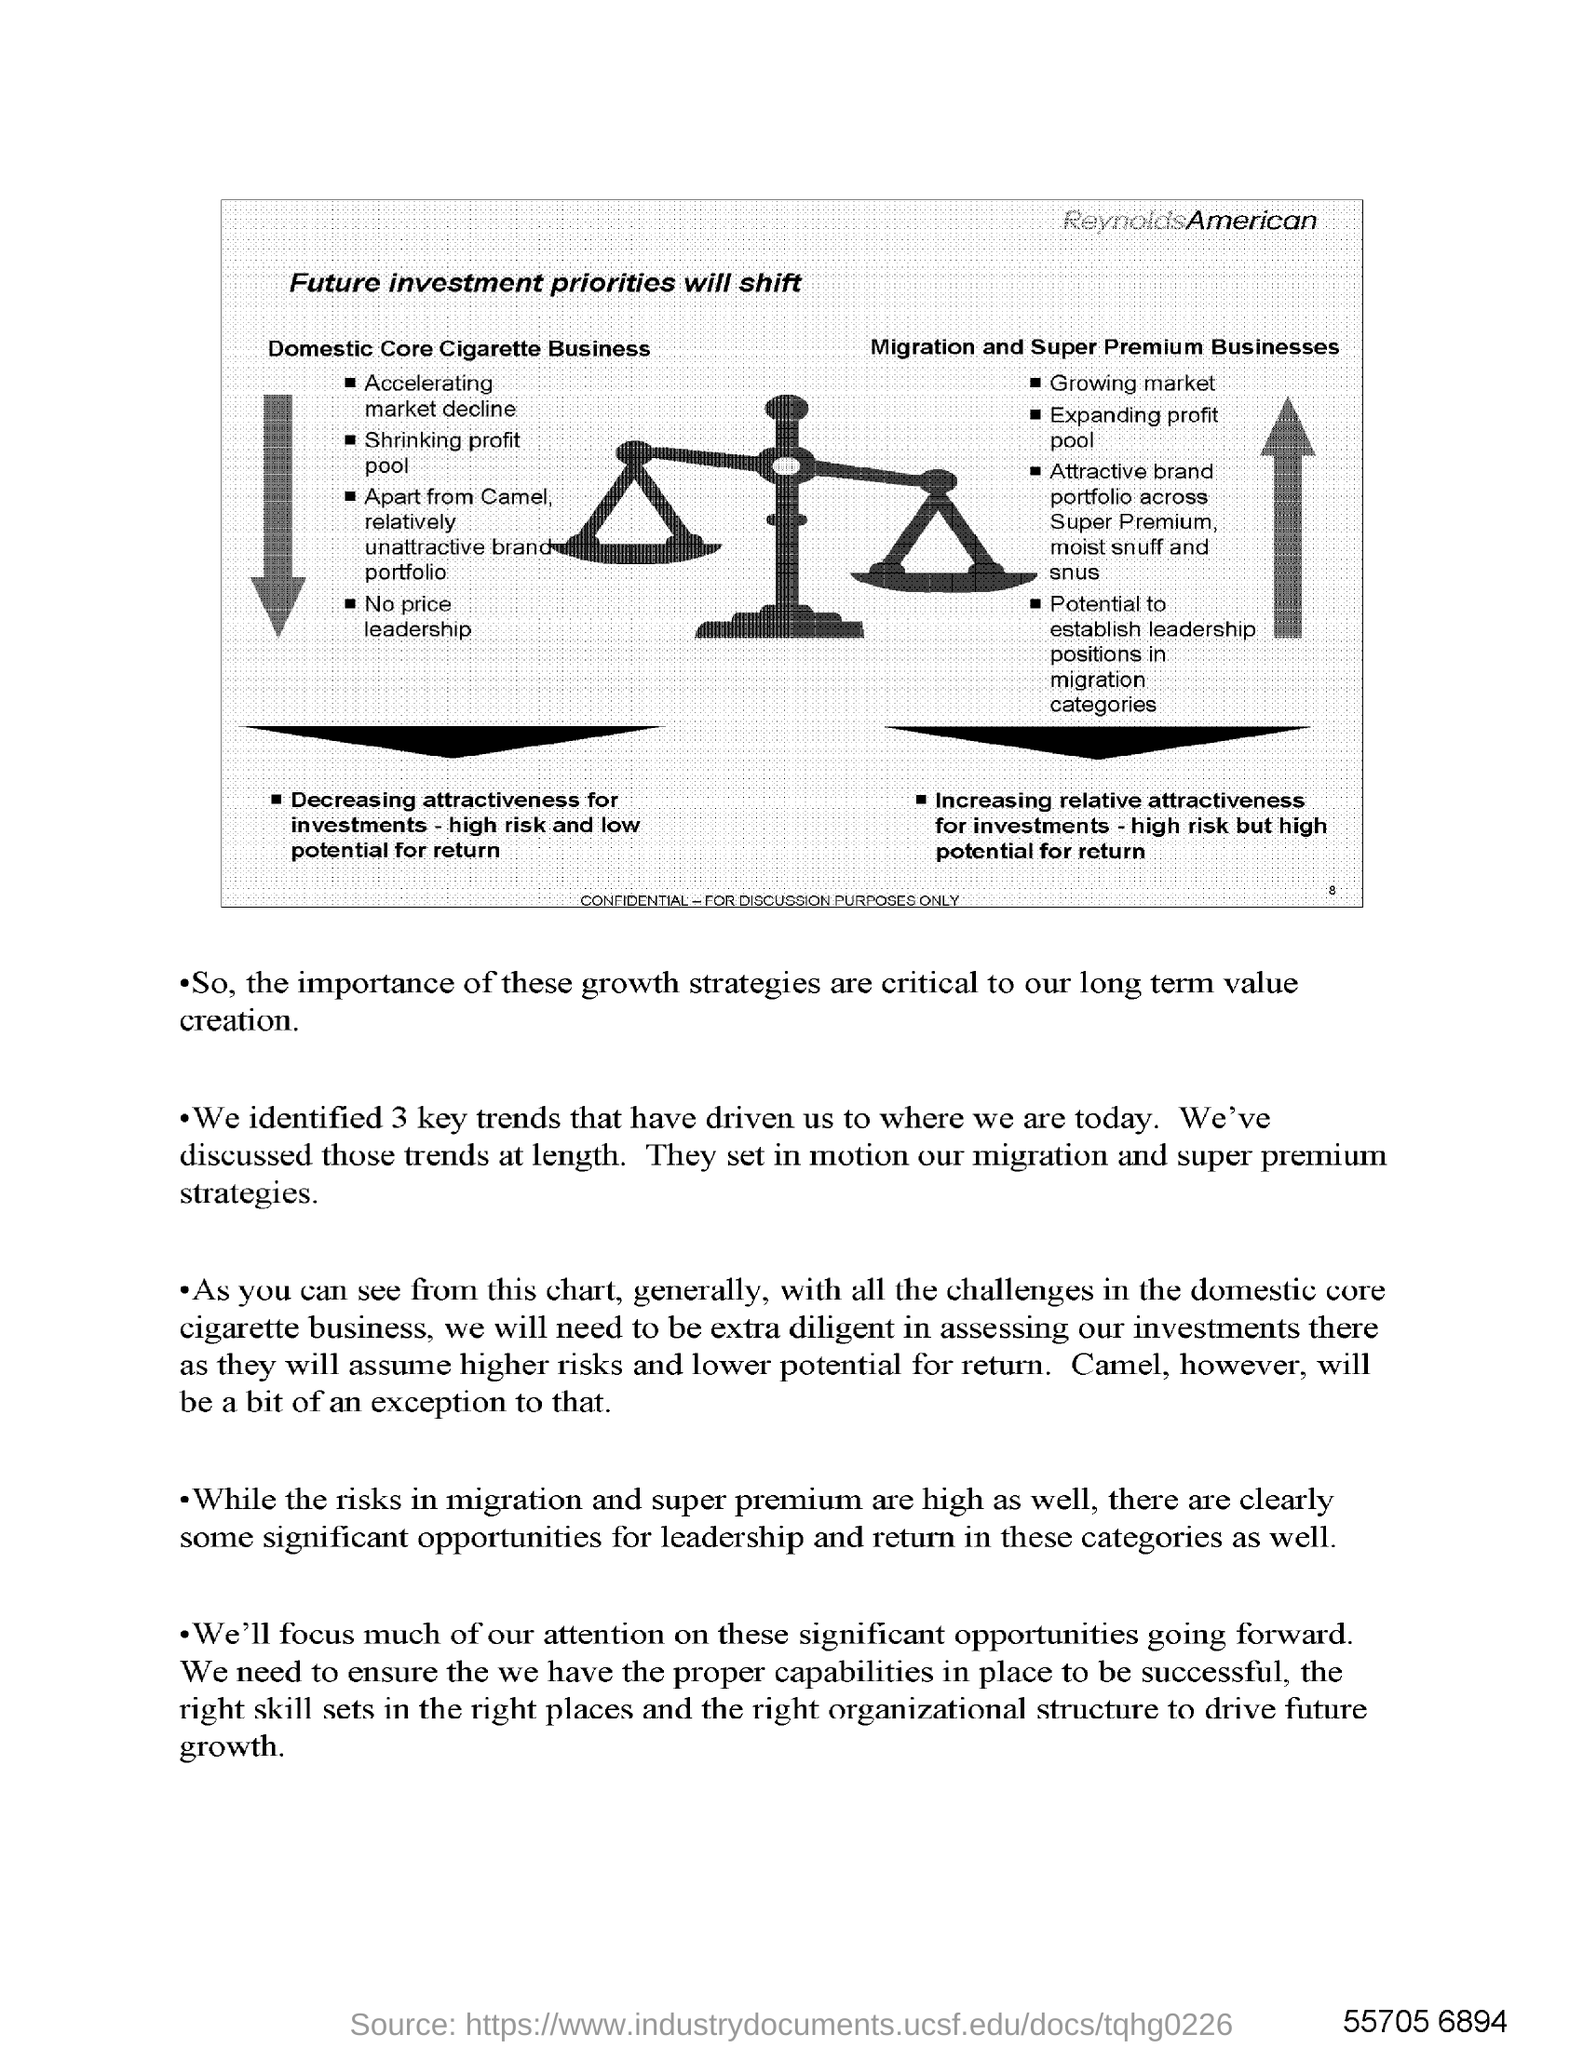Mention a couple of crucial points in this snapshot. The text written in the top right corner of the image is "ReynoldsAmerican. 